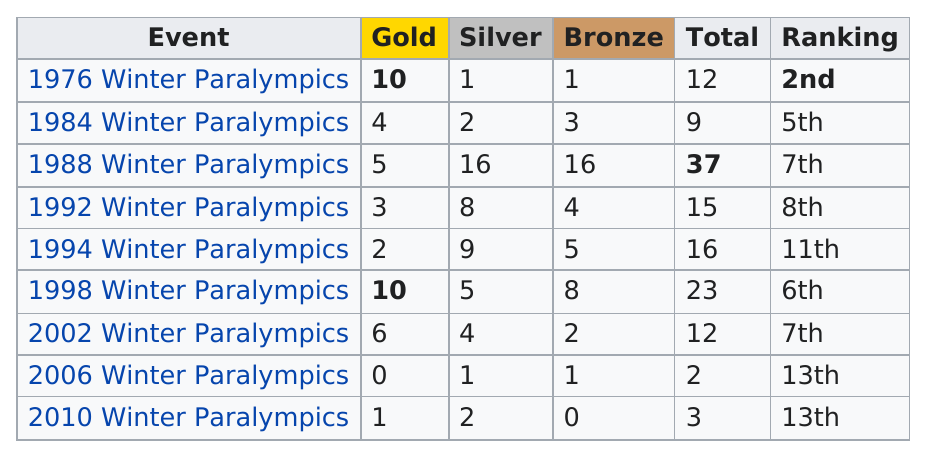Draw attention to some important aspects in this diagram. In the year that Switzerland earned no gold medals, it earned one silver medal. In 1992, Switzerland did not win 10 gold medals at the Winter Paralympics. The 1988 Winter Paralympics had the largest number of medals overall. In the 2010 Winter Paralympics, Switzerland won the same amount of silver medals as they did in the 1984 Winter Paralympics. The highest ranking year for the band "The Band" was 1976. 